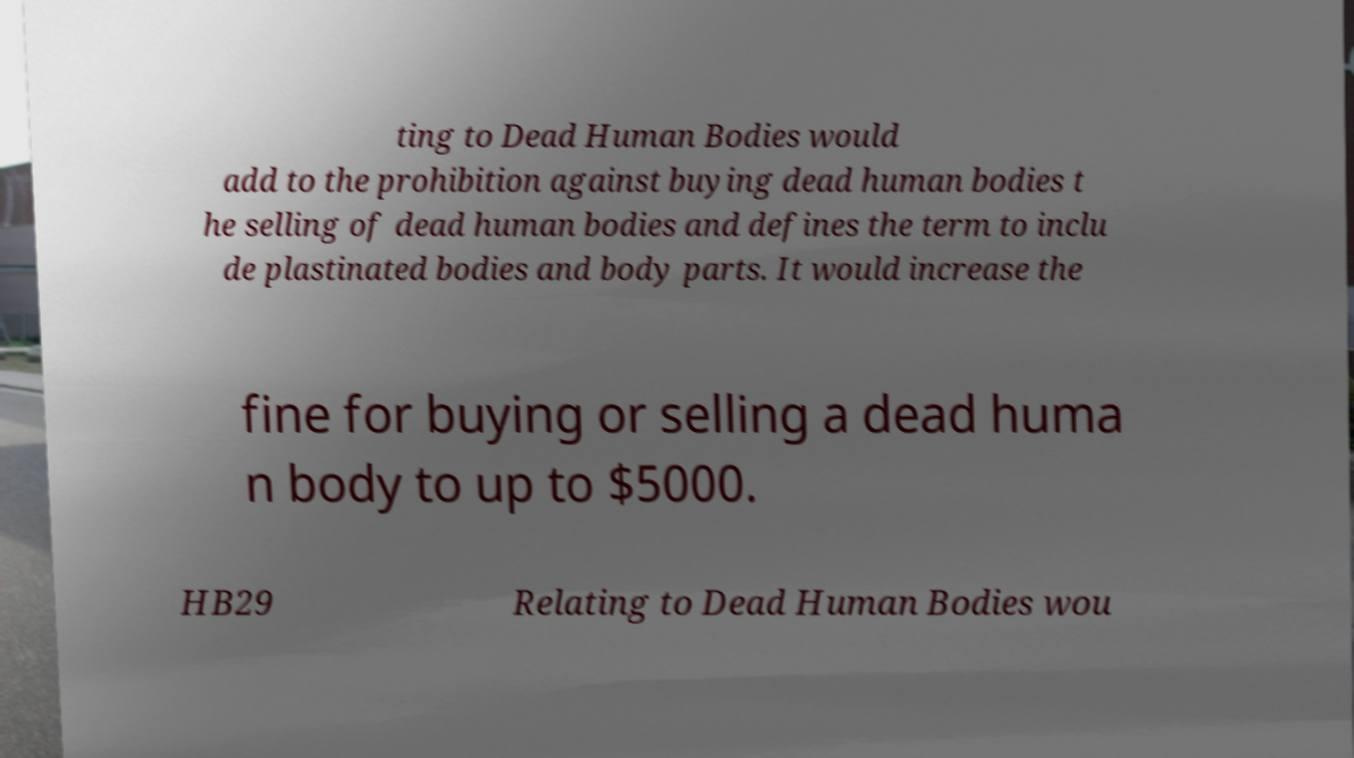There's text embedded in this image that I need extracted. Can you transcribe it verbatim? ting to Dead Human Bodies would add to the prohibition against buying dead human bodies t he selling of dead human bodies and defines the term to inclu de plastinated bodies and body parts. It would increase the fine for buying or selling a dead huma n body to up to $5000. HB29 Relating to Dead Human Bodies wou 